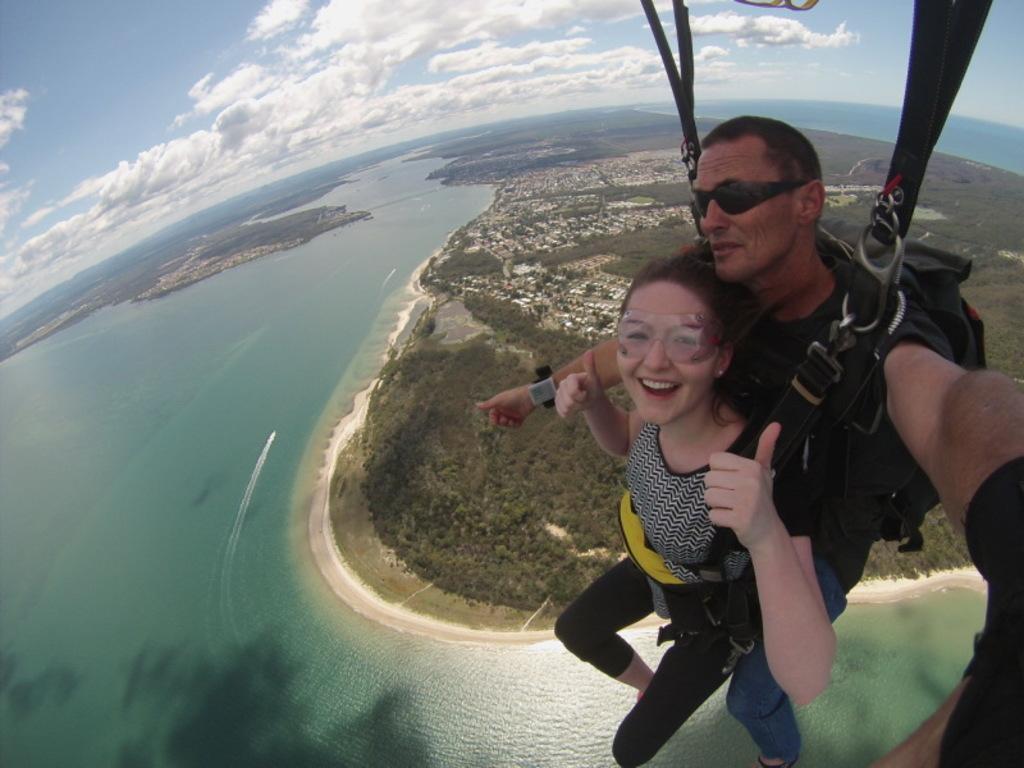Describe this image in one or two sentences. In this image there are two persons who are wearing same belts, and they are in air. At the bottom there is an ocean, trees, buildings and at the top of the image there is sky. 